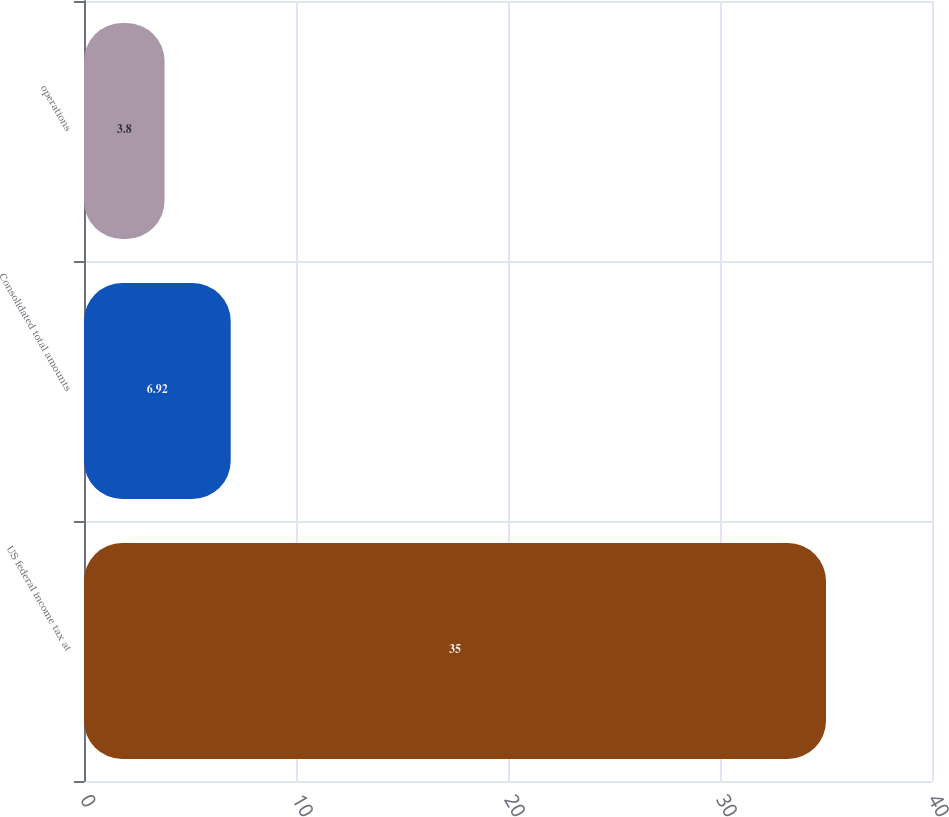<chart> <loc_0><loc_0><loc_500><loc_500><bar_chart><fcel>US federal income tax at<fcel>Consolidated total amounts<fcel>operations<nl><fcel>35<fcel>6.92<fcel>3.8<nl></chart> 